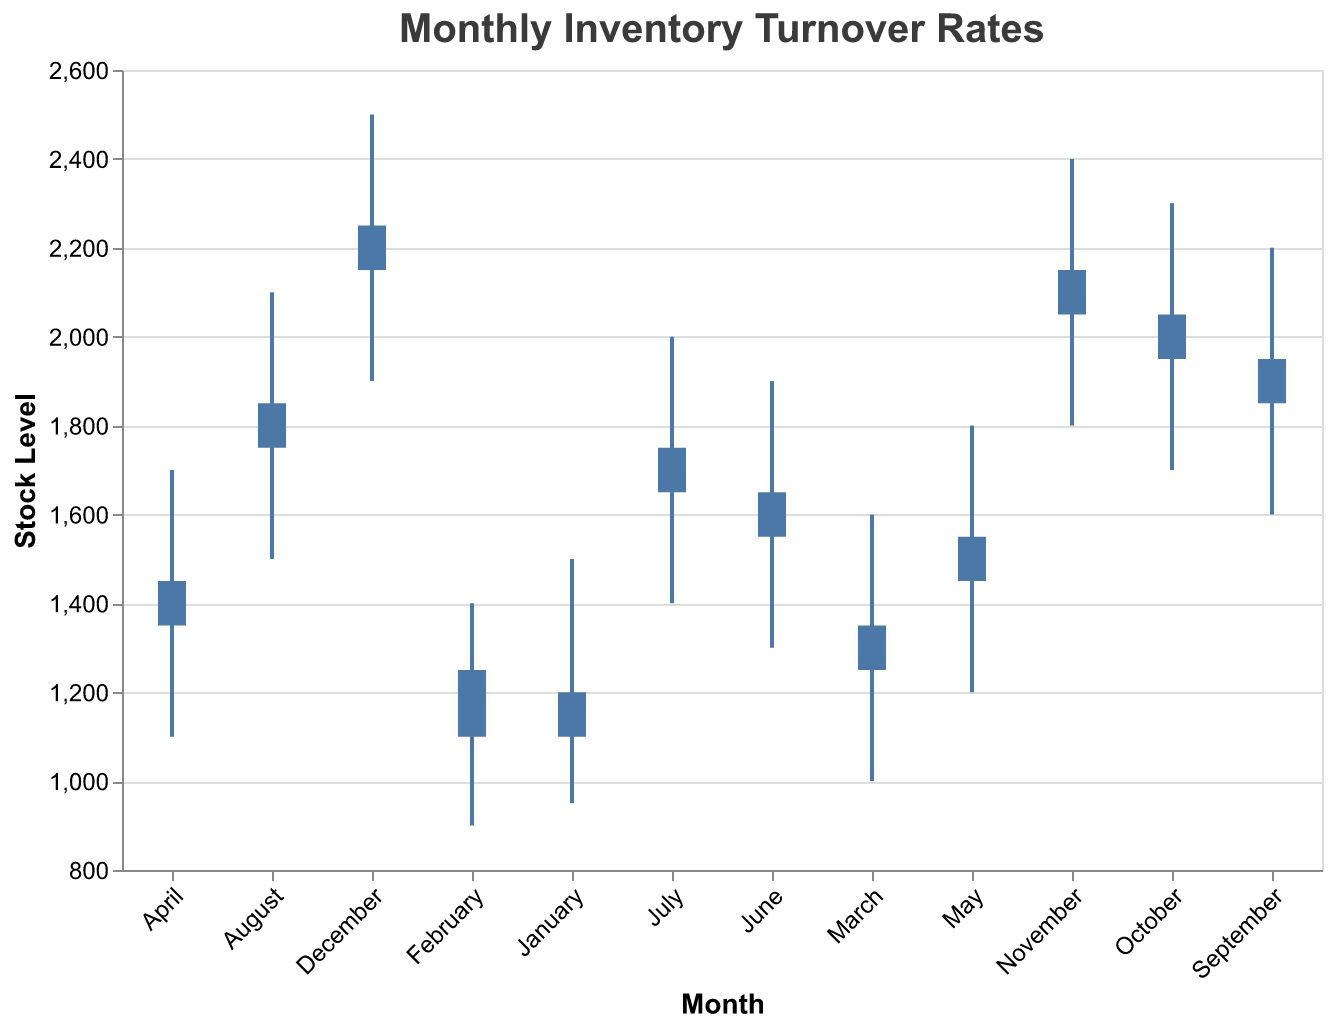What is the title of the chart? The title of the chart is located at the top and is clearly displayed in a larger font for emphasis. It's designed to provide an immediate understanding of the chart’s content.
Answer: Monthly Inventory Turnover Rates Which month had the highest initial stock level and what was it? To find the month with the highest initial stock level, look for the starting bar that is the highest on the y-axis. This usually corresponds to the final month in a cumulative increase scenario.
Answer: December with 2150 In which months did the end-of-month stock surpass the initial stock level? To determine this, compare the positions of the top end of each bar (initial stock) with the tick marks at the end of the bar (end-of-month stock). Identify instances where the tick mark is higher than the top of the bar.
Answer: February, March, May, July, August, October, November, December What is the average initial stock level in the first quarter (January, February, March)? Add the initial stock values for January, February, and March, then divide by the number of months (3). Calculation: (1200 + 1100 + 1250) / 3.
Answer: 1183.33 Which month saw the greatest difference between the highest and lowest stock levels? Subtract the lowest level from the highest level for each month and identify the month with the largest resulting value. Comparison: 1500-950, 1400-900, 1600-1000, etc.
Answer: October In which month was the end-of-month stock at its lowest? Identify the lowest end-of-month tick mark across all months by looking at the right side of the bars where the blue ticks are marked.
Answer: January How much did the initial stock increase from July to August? Subtract July’s initial stock from August’s initial stock. Calculation: 1750 - 1650.
Answer: 100 By how much did the initial stock level change from January to December? Subtract January’s initial stock value from December’s initial stock value. Calculation: 2150 - 1200.
Answer: 950 Which two consecutive months had the smallest increase in end-of-month stock? Compare the increase in end-of-month stock from month to month and identify the smallest difference. Comparison: (1250-1100), (1350-1250), etc.
Answer: November to December What was the highest recorded stock level in the year and during which month? Look for the maximum value on the y-axis across all months for the highest level.
Answer: December with 2500 